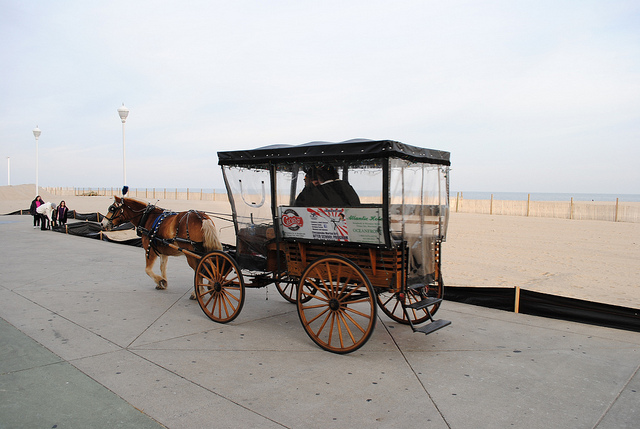<image>Are there fruits or vegetables are the cart? I am not sure if there are fruits or vegetables on the cart. It could be either way. Are there fruits or vegetables are the cart? I don't know if there are fruits or vegetables in the cart. It is ambiguous. 